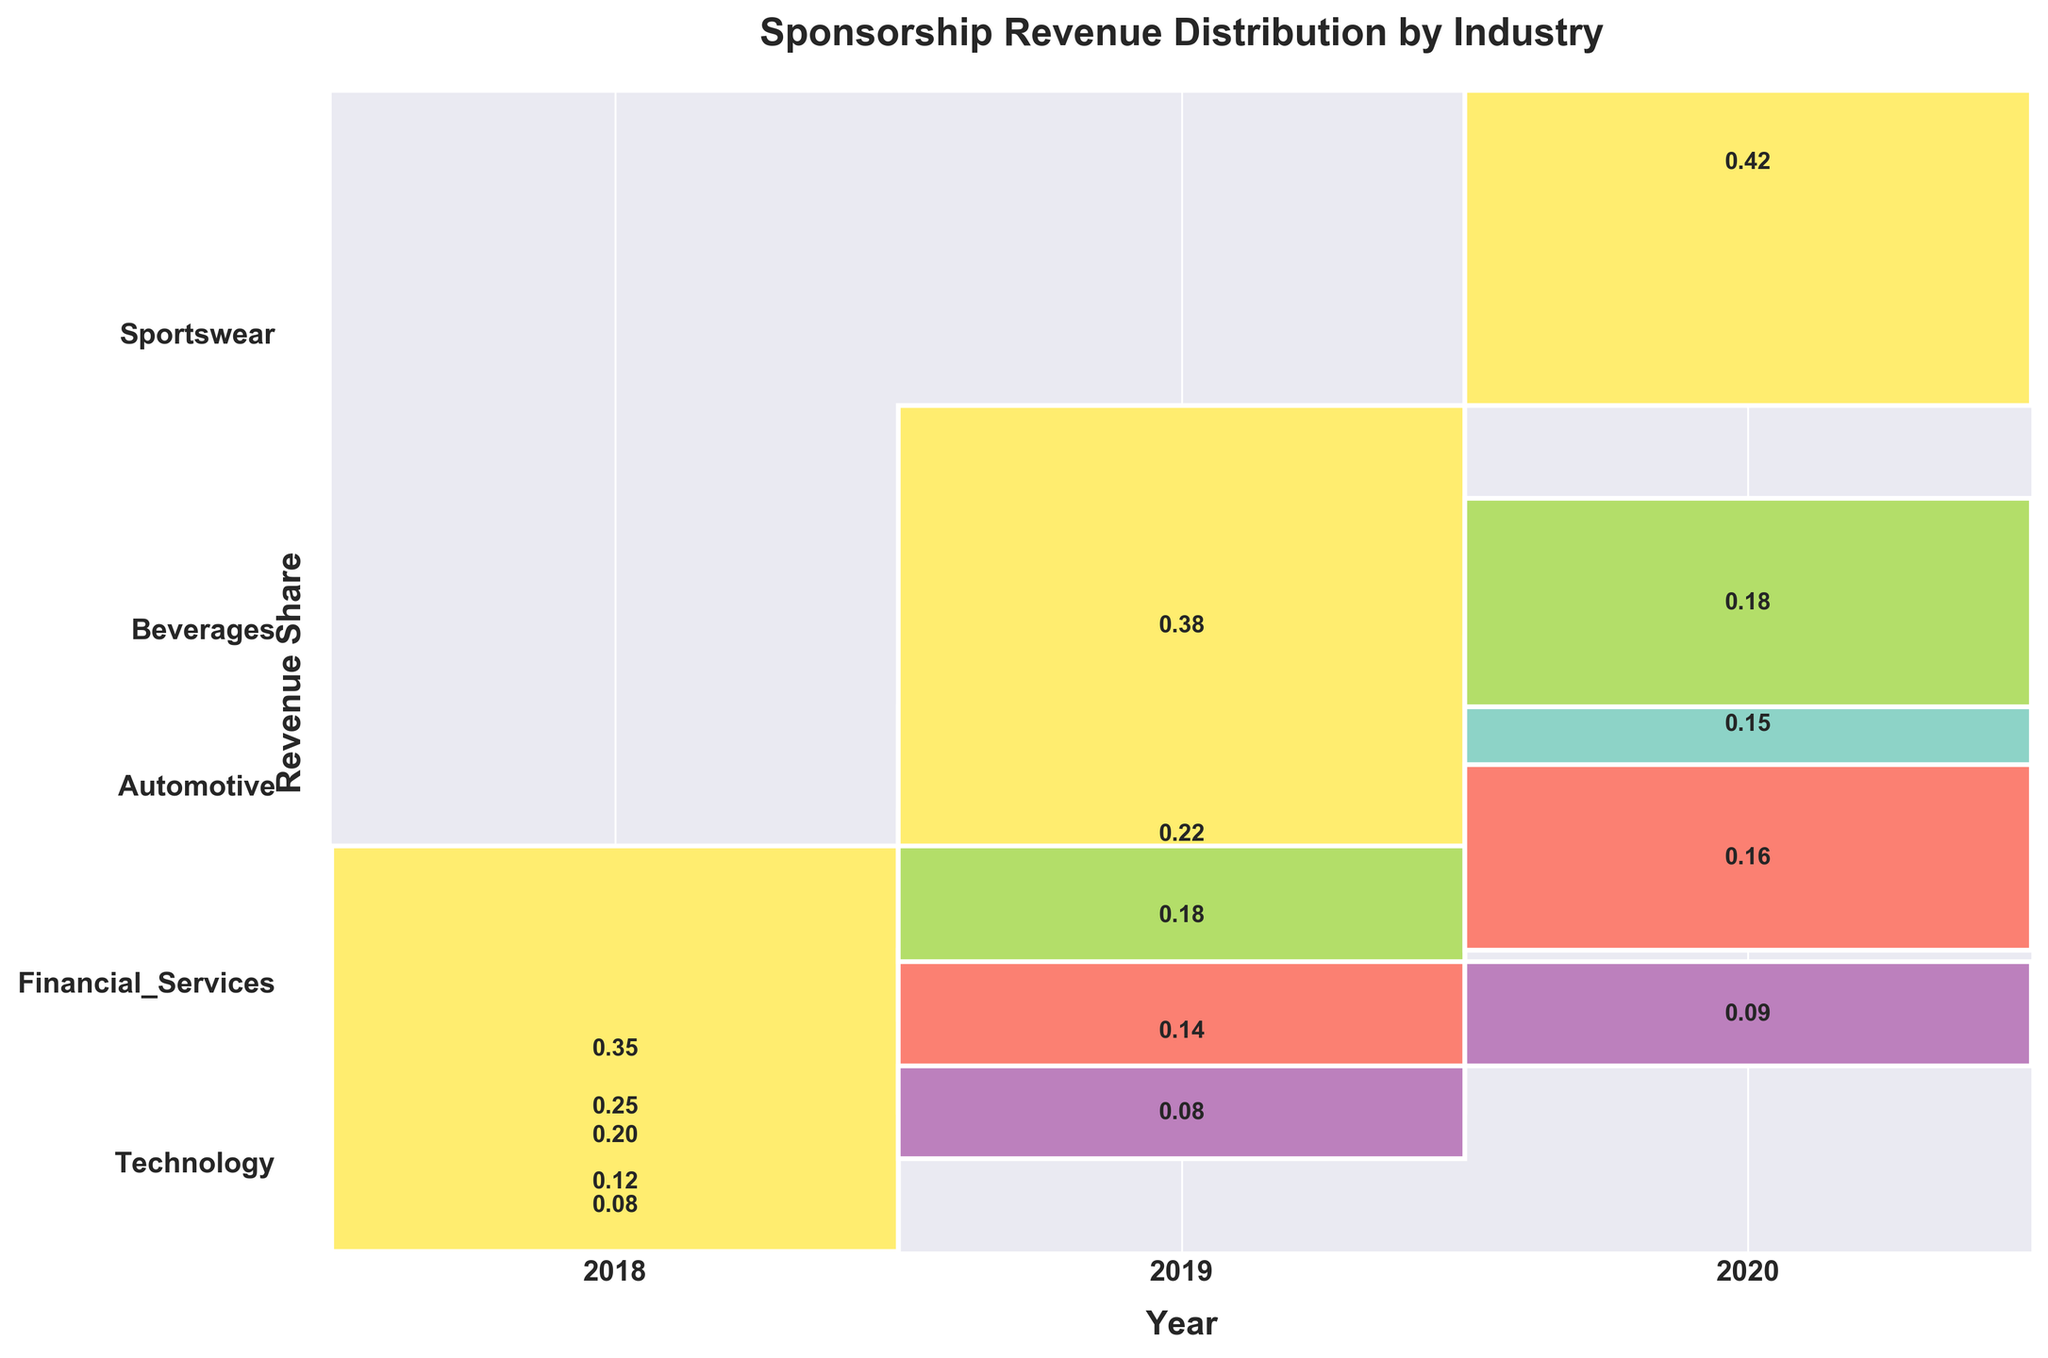Which industry had the highest sponsorship revenue share in 2020? Look at the 2020 column and find the industry with the tallest rectangle. It is Technology with 0.42.
Answer: Technology What trend is observed for Financial Services from 2018 to 2020? Compare the heights of the Financial Services rectangles from each year. The height decreases from 0.25 in 2018 to 0.22 in 2019, and further to 0.18 in 2020, indicating a declining trend.
Answer: Decline Which industry maintained a constant revenue share throughout the years? Examine each industry's rectangles over the three years. Sportswear maintains the same revenue share of 0.08 in 2018 and 2019, and slightly increases to 0.09 in 2020. This is the least variation compared to others.
Answer: Sportswear How did the revenue share for Beverages change from 2018 to 2020? Compare the heights of the Beverages rectangles for each year. It increased from 0.12 in 2018 to 0.14 in 2019, and further to 0.16 in 2020.
Answer: Increased In 2019, which industry had the second highest revenue share? Look at the 2019 column and identify the second tallest rectangle. It is Financial Services with 0.22 after Technology with 0.38.
Answer: Financial Services What is the combined revenue share of Automotive and Beverages in 2020? Add the heights of the Automotive (0.15) and Beverages (0.16) rectangles for 2020. 0.15 + 0.16 = 0.31.
Answer: 0.31 Which industry sector had the least sponsorship revenue share in 2018? Find the industry with the shortest rectangle in 2018. It is Sportswear with 0.08.
Answer: Sportswear What is the total sponsorship revenue share for all industries in 2018? Sum the revenue shares for all industries in 2018: 0.35 (Technology) + 0.25 (Financial Services) + 0.20 (Automotive) + 0.12 (Beverages) + 0.08 (Sportswear). 0.35 + 0.25 + 0.20 + 0.12 + 0.08 = 1.
Answer: 1 